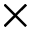Convert formula to latex. <formula><loc_0><loc_0><loc_500><loc_500>\times</formula> 